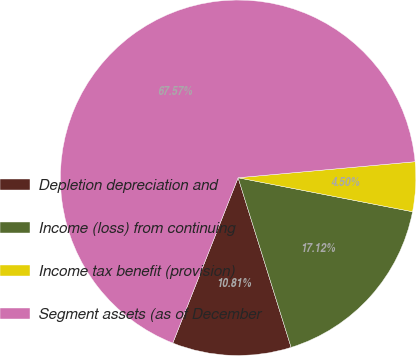Convert chart to OTSL. <chart><loc_0><loc_0><loc_500><loc_500><pie_chart><fcel>Depletion depreciation and<fcel>Income (loss) from continuing<fcel>Income tax benefit (provision)<fcel>Segment assets (as of December<nl><fcel>10.81%<fcel>17.12%<fcel>4.5%<fcel>67.58%<nl></chart> 